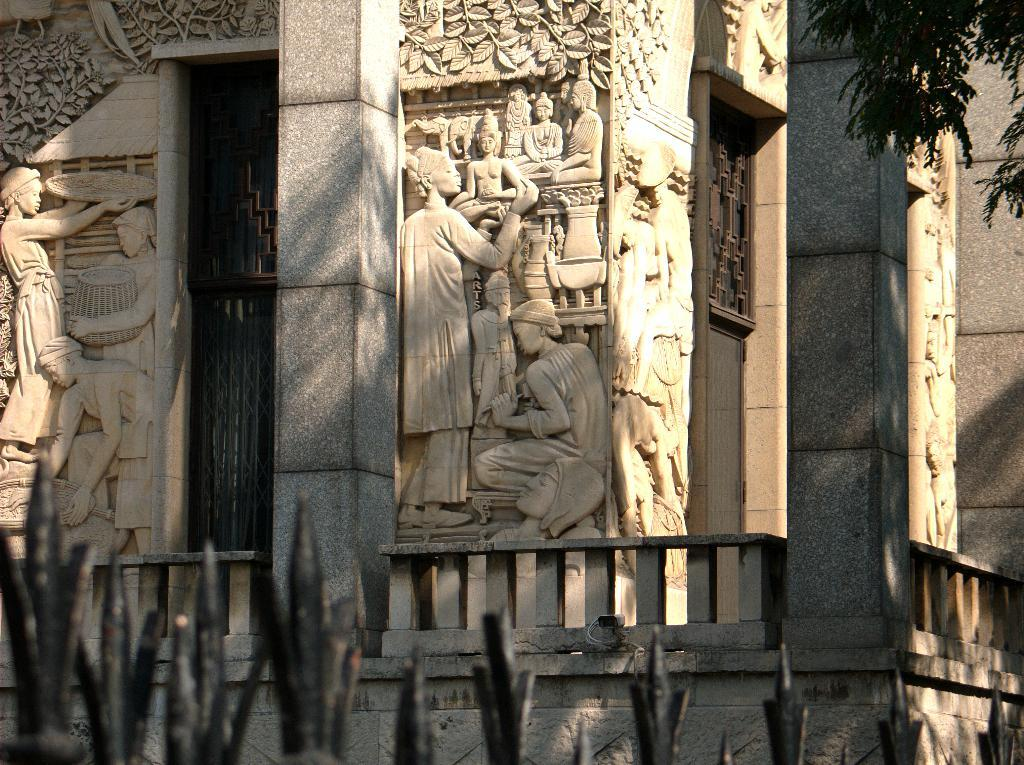What can be seen on the walls in the image? There are carvings on the walls in the image. What type of material are the objects made of in the image? There are iron objects in the image. Can you describe any other objects present in the image? Yes, there are other objects in the image. What is visible on the right side top of the image? There appears to be a tree on the right side top of the image. What scent is emitted by the carvings in the image? There is no information about the scent of the carvings in the image, as the focus is on their appearance and not their smell. 